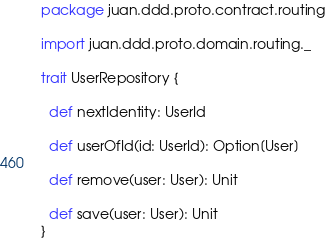Convert code to text. <code><loc_0><loc_0><loc_500><loc_500><_Scala_>package juan.ddd.proto.contract.routing

import juan.ddd.proto.domain.routing._

trait UserRepository {

  def nextIdentity: UserId

  def userOfId(id: UserId): Option[User]

  def remove(user: User): Unit

  def save(user: User): Unit
}
</code> 